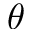Convert formula to latex. <formula><loc_0><loc_0><loc_500><loc_500>\theta</formula> 